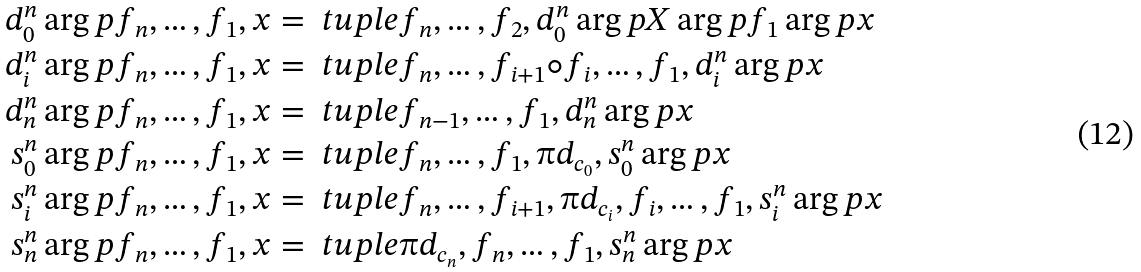<formula> <loc_0><loc_0><loc_500><loc_500>d ^ { n } _ { 0 } \arg p { f _ { n } , \dots , f _ { 1 } , x } & = \ t u p l e { f _ { n } , \dots , f _ { 2 } , d ^ { n } _ { 0 } \arg p { X \arg p { f _ { 1 } } \arg p { x } } } \\ d ^ { n } _ { i } \arg p { f _ { n } , \dots , f _ { 1 } , x } & = \ t u p l e { f _ { n } , \dots , f _ { i + 1 } \circ f _ { i } , \dots , f _ { 1 } , d ^ { n } _ { i } \arg p { x } } \\ d ^ { n } _ { n } \arg p { f _ { n } , \dots , f _ { 1 } , x } & = \ t u p l e { f _ { n - 1 } , \dots , f _ { 1 } , d ^ { n } _ { n } \arg p { x } } \\ s ^ { n } _ { 0 } \arg p { f _ { n } , \dots , f _ { 1 } , x } & = \ t u p l e { f _ { n } , \dots , f _ { 1 } , \i d _ { c _ { 0 } } , s ^ { n } _ { 0 } \arg p { x } } \\ s ^ { n } _ { i } \arg p { f _ { n } , \dots , f _ { 1 } , x } & = \ t u p l e { f _ { n } , \dots , f _ { i + 1 } , \i d _ { c _ { i } } , f _ { i } , \dots , f _ { 1 } , s ^ { n } _ { i } \arg p { x } } \\ s ^ { n } _ { n } \arg p { f _ { n } , \dots , f _ { 1 } , x } & = \ t u p l e { \i d _ { c _ { n } } , f _ { n } , \dots , f _ { 1 } , s ^ { n } _ { n } \arg p { x } }</formula> 